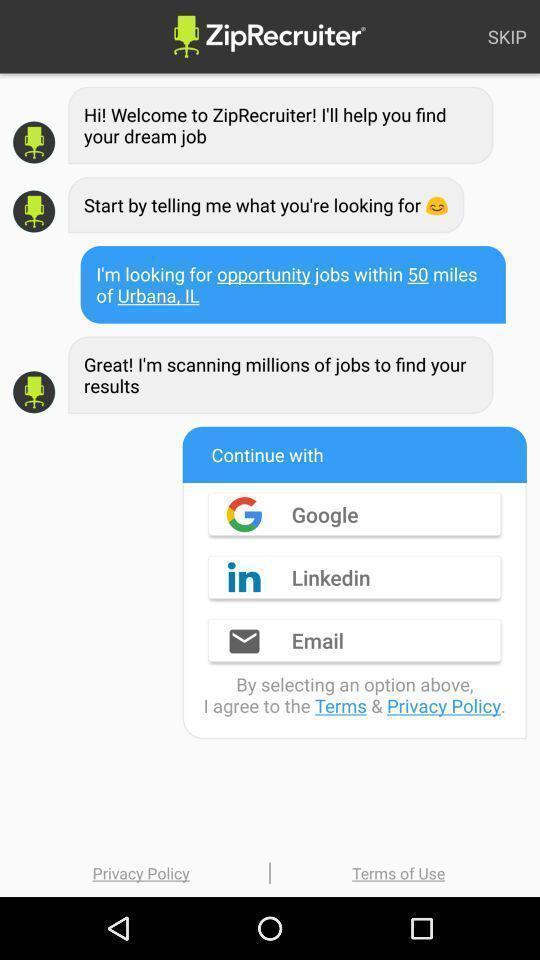Describe the visual elements of this screenshot. Page showing chatting messages in the job finding app. 